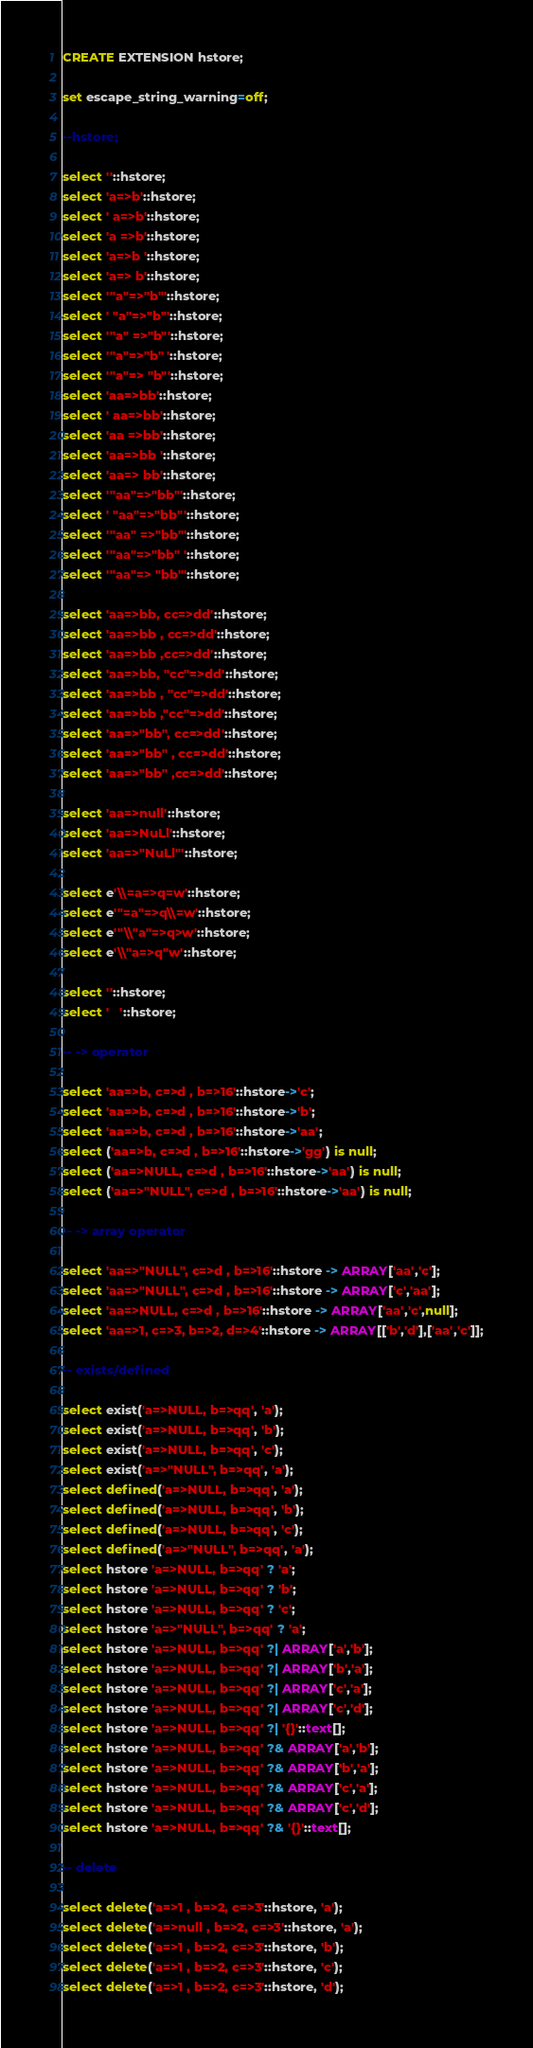<code> <loc_0><loc_0><loc_500><loc_500><_SQL_>CREATE EXTENSION hstore;

set escape_string_warning=off;

--hstore;

select ''::hstore;
select 'a=>b'::hstore;
select ' a=>b'::hstore;
select 'a =>b'::hstore;
select 'a=>b '::hstore;
select 'a=> b'::hstore;
select '"a"=>"b"'::hstore;
select ' "a"=>"b"'::hstore;
select '"a" =>"b"'::hstore;
select '"a"=>"b" '::hstore;
select '"a"=> "b"'::hstore;
select 'aa=>bb'::hstore;
select ' aa=>bb'::hstore;
select 'aa =>bb'::hstore;
select 'aa=>bb '::hstore;
select 'aa=> bb'::hstore;
select '"aa"=>"bb"'::hstore;
select ' "aa"=>"bb"'::hstore;
select '"aa" =>"bb"'::hstore;
select '"aa"=>"bb" '::hstore;
select '"aa"=> "bb"'::hstore;

select 'aa=>bb, cc=>dd'::hstore;
select 'aa=>bb , cc=>dd'::hstore;
select 'aa=>bb ,cc=>dd'::hstore;
select 'aa=>bb, "cc"=>dd'::hstore;
select 'aa=>bb , "cc"=>dd'::hstore;
select 'aa=>bb ,"cc"=>dd'::hstore;
select 'aa=>"bb", cc=>dd'::hstore;
select 'aa=>"bb" , cc=>dd'::hstore;
select 'aa=>"bb" ,cc=>dd'::hstore;

select 'aa=>null'::hstore;
select 'aa=>NuLl'::hstore;
select 'aa=>"NuLl"'::hstore;

select e'\\=a=>q=w'::hstore;
select e'"=a"=>q\\=w'::hstore;
select e'"\\"a"=>q>w'::hstore;
select e'\\"a=>q"w'::hstore;

select ''::hstore;
select '	'::hstore;

-- -> operator

select 'aa=>b, c=>d , b=>16'::hstore->'c';
select 'aa=>b, c=>d , b=>16'::hstore->'b';
select 'aa=>b, c=>d , b=>16'::hstore->'aa';
select ('aa=>b, c=>d , b=>16'::hstore->'gg') is null;
select ('aa=>NULL, c=>d , b=>16'::hstore->'aa') is null;
select ('aa=>"NULL", c=>d , b=>16'::hstore->'aa') is null;

-- -> array operator

select 'aa=>"NULL", c=>d , b=>16'::hstore -> ARRAY['aa','c'];
select 'aa=>"NULL", c=>d , b=>16'::hstore -> ARRAY['c','aa'];
select 'aa=>NULL, c=>d , b=>16'::hstore -> ARRAY['aa','c',null];
select 'aa=>1, c=>3, b=>2, d=>4'::hstore -> ARRAY[['b','d'],['aa','c']];

-- exists/defined

select exist('a=>NULL, b=>qq', 'a');
select exist('a=>NULL, b=>qq', 'b');
select exist('a=>NULL, b=>qq', 'c');
select exist('a=>"NULL", b=>qq', 'a');
select defined('a=>NULL, b=>qq', 'a');
select defined('a=>NULL, b=>qq', 'b');
select defined('a=>NULL, b=>qq', 'c');
select defined('a=>"NULL", b=>qq', 'a');
select hstore 'a=>NULL, b=>qq' ? 'a';
select hstore 'a=>NULL, b=>qq' ? 'b';
select hstore 'a=>NULL, b=>qq' ? 'c';
select hstore 'a=>"NULL", b=>qq' ? 'a';
select hstore 'a=>NULL, b=>qq' ?| ARRAY['a','b'];
select hstore 'a=>NULL, b=>qq' ?| ARRAY['b','a'];
select hstore 'a=>NULL, b=>qq' ?| ARRAY['c','a'];
select hstore 'a=>NULL, b=>qq' ?| ARRAY['c','d'];
select hstore 'a=>NULL, b=>qq' ?| '{}'::text[];
select hstore 'a=>NULL, b=>qq' ?& ARRAY['a','b'];
select hstore 'a=>NULL, b=>qq' ?& ARRAY['b','a'];
select hstore 'a=>NULL, b=>qq' ?& ARRAY['c','a'];
select hstore 'a=>NULL, b=>qq' ?& ARRAY['c','d'];
select hstore 'a=>NULL, b=>qq' ?& '{}'::text[];

-- delete

select delete('a=>1 , b=>2, c=>3'::hstore, 'a');
select delete('a=>null , b=>2, c=>3'::hstore, 'a');
select delete('a=>1 , b=>2, c=>3'::hstore, 'b');
select delete('a=>1 , b=>2, c=>3'::hstore, 'c');
select delete('a=>1 , b=>2, c=>3'::hstore, 'd');</code> 